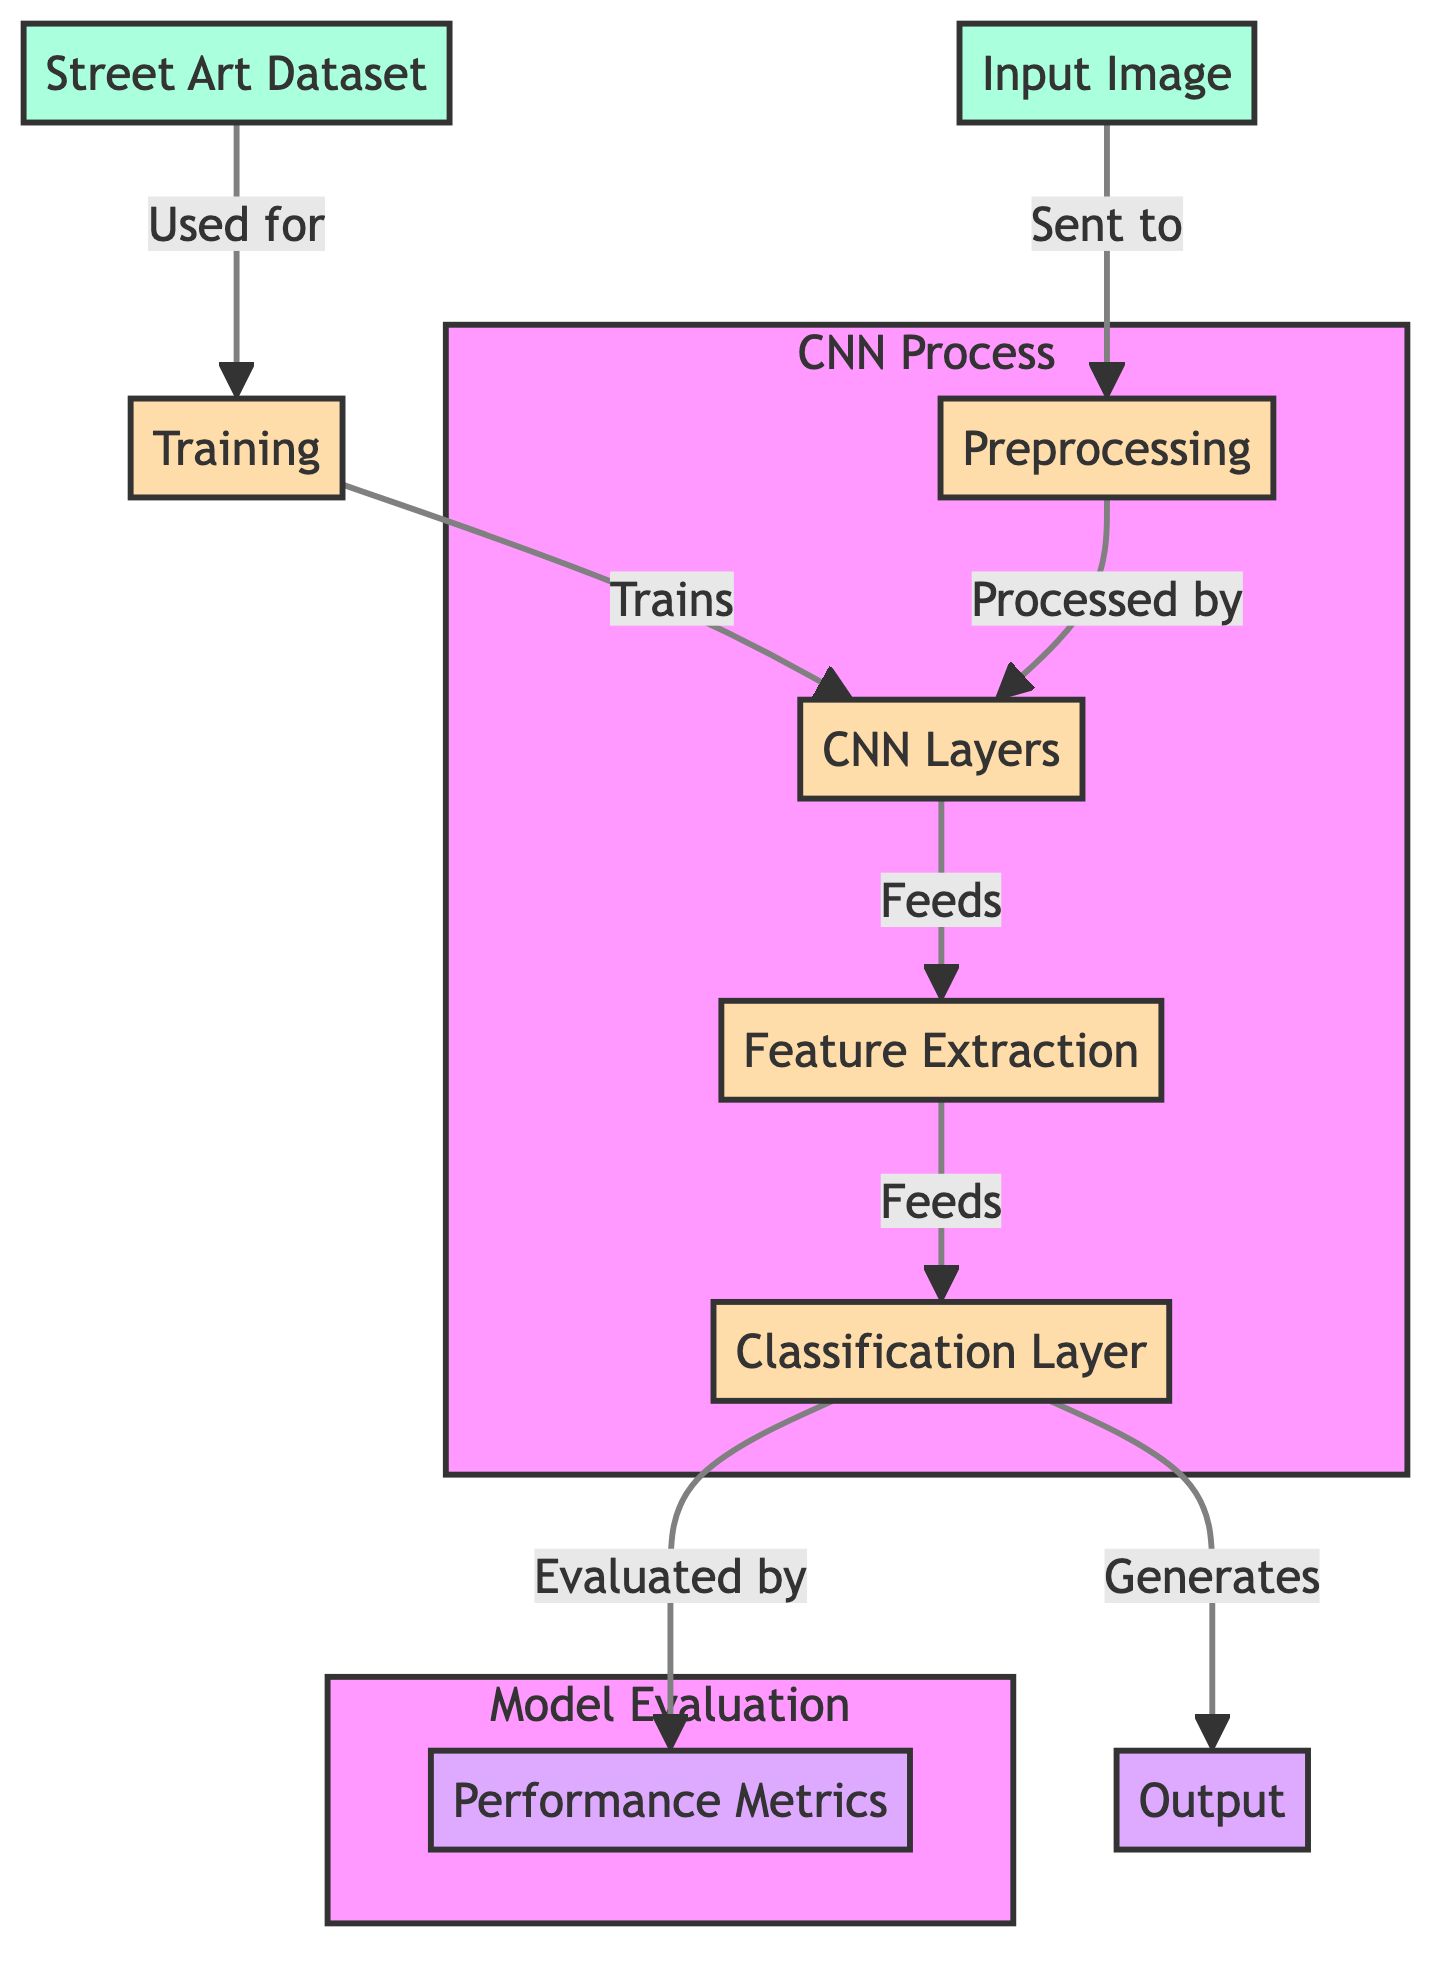What is the first step after the input image is sent? The diagram shows that after the input image is sent, it undergoes preprocessing. This is the direct connection from the input image to the preprocessing node.
Answer: Preprocessing How many main nodes are in the CNN process? The CNN process includes four main nodes: preprocessing, cnn layers, feature extraction, and classification layer. Counting these nodes gives us four in total.
Answer: Four What is produced by the classification layer? The classification layer generates the output, as denoted by the arrow connecting the classification layer to the output node.
Answer: Output What evaluates the classification layer? The performance metrics node is responsible for evaluating the classification layer's output based on the diagram’s connections.
Answer: Performance metrics Which dataset is used for training? The dataset labeled "Street Art Dataset" is utilized for training according to the diagram, as indicated by the directed arrow from the dataset to the training node.
Answer: Street Art Dataset How many different processes are involved in the CNN process? Within the CNN process, there are three distinct processes that appear to feed into each other: cnn layers, feature extraction, and classification layer, plus preprocessing, leading to a total of four.
Answer: Four Which section contains the node for performance metrics? The diagram clearly indicates that the performance metrics node is part of the Model Evaluation subgraph, as shown in the labeled division of the diagram.
Answer: Model Evaluation What is the relationship between training and cnn layers? The diagram shows that training actively trains the cnn layers, indicated by the directed arrow from the training node to the cnn layers node.
Answer: Trains 